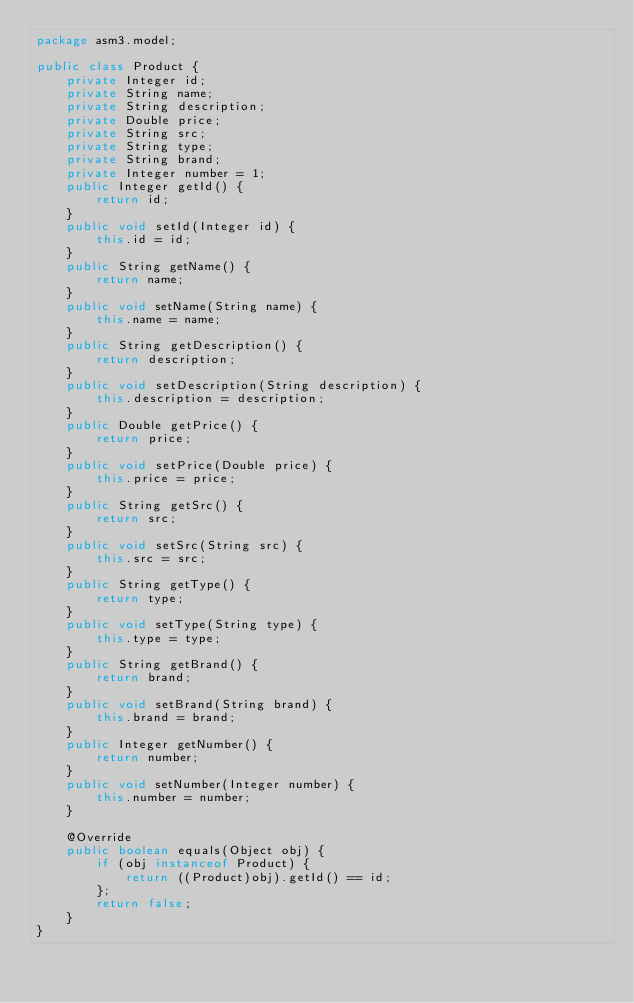Convert code to text. <code><loc_0><loc_0><loc_500><loc_500><_Java_>package asm3.model;

public class Product {
	private Integer id;
	private String name;
	private String description;
	private Double price;
	private String src;
	private String type;
	private String brand;
	private Integer number = 1;
	public Integer getId() {
		return id;
	}
	public void setId(Integer id) {
		this.id = id;
	}
	public String getName() {
		return name;
	}
	public void setName(String name) {
		this.name = name;
	}
	public String getDescription() {
		return description;
	}
	public void setDescription(String description) {
		this.description = description;
	}
	public Double getPrice() {
		return price;
	}
	public void setPrice(Double price) {
		this.price = price;
	}
	public String getSrc() {
		return src;
	}
	public void setSrc(String src) {
		this.src = src;
	}
	public String getType() {
		return type;
	}
	public void setType(String type) {
		this.type = type;
	}
	public String getBrand() {
		return brand;
	}
	public void setBrand(String brand) {
		this.brand = brand;
	}
	public Integer getNumber() {
		return number;
	}
	public void setNumber(Integer number) {
		this.number = number;
	}
	
	@Override
	public boolean equals(Object obj) {
		if (obj instanceof Product) {
			return ((Product)obj).getId() == id;
		};
		return false;
	}
}
</code> 